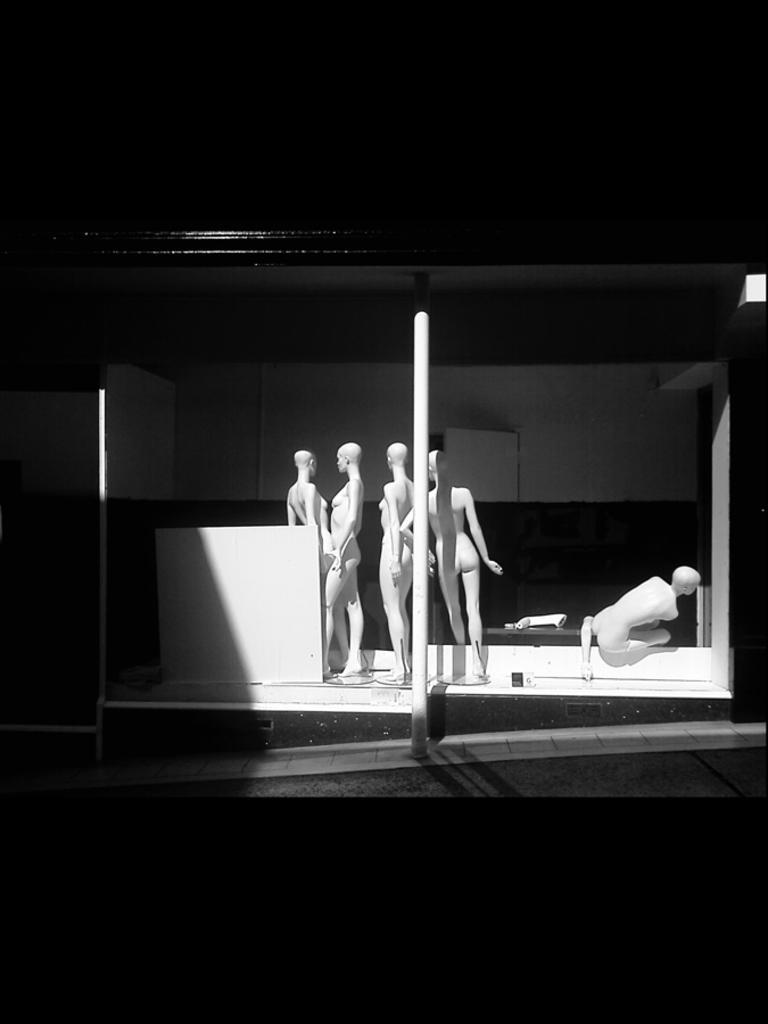In one or two sentences, can you explain what this image depicts? In the center of the image there are depictions of people. There is a pole. In the background of the image there is wall. 